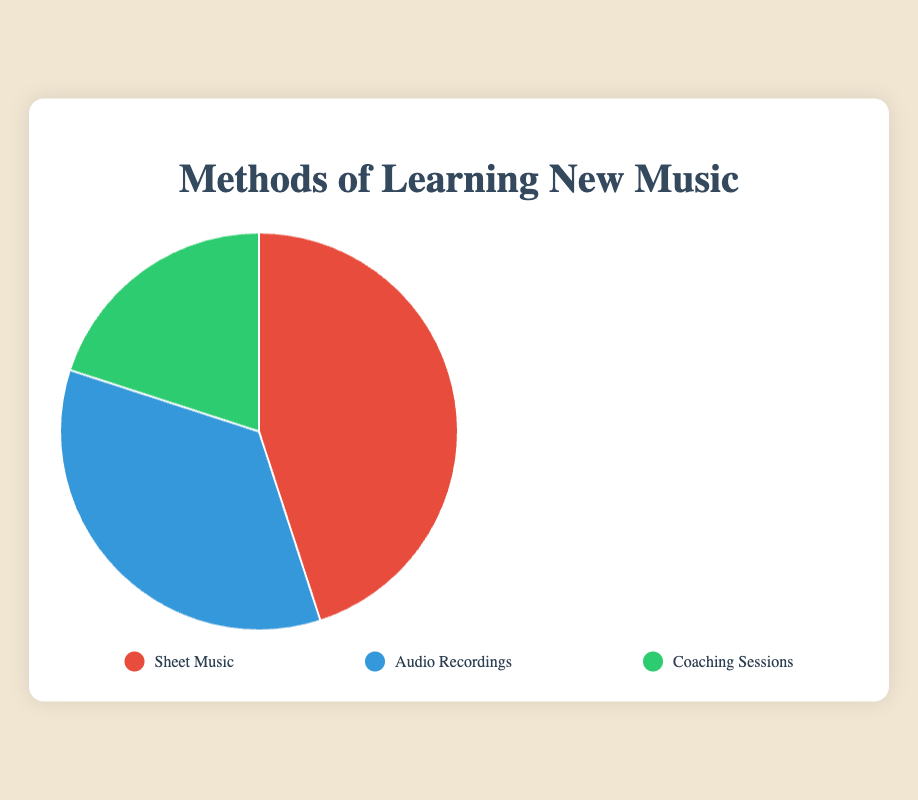What percentage of methods use Sheet Music? According to the pie chart, the percentage for Sheet Music is clearly indicated.
Answer: 45% What is the combined percentage of methods that use Audio Recordings and Coaching Sessions? The pie chart shows that Audio Recordings account for 35% and Coaching Sessions account for 20%. Summing these together, 35% + 20% gives the total percentage.
Answer: 55% Which method of learning new music is the most popular based on the chart? The largest segment in the pie chart corresponds to Sheet Music, with the highest percentage of 45%.
Answer: Sheet Music How many percentage points more does Sheet Music have compared to Coaching Sessions? Sheet Music has 45% and Coaching Sessions have 20%. The difference is calculated as 45% - 20%.
Answer: 25 What is the average percentage of all three methods combined? To find the average, we sum the percentages of all three methods: 45% + 35% + 20% = 100%. Then, we divide by the number of methods, which is 3. Thus, the average is 100% / 3.
Answer: 33.3% Which method has the smallest percentage, and what is it? The pie chart shows the smallest segment corresponds to Coaching Sessions, with a percentage of 20%.
Answer: Coaching Sessions, 20% Is the percentage of Audio Recordings greater than the percentage of Coaching Sessions? Yes, the percentage for Audio Recordings is 35%, while Coaching Sessions have 20%. Thus, 35% is greater than 20%.
Answer: Yes By how many more percentage points does Sheet Music surpass Audio Recordings? Sheet Music has 45% and Audio Recordings have 35%. The difference is calculated by subtracting 35% from 45%.
Answer: 10 How do the percentages of Audio Recordings and Coaching Sessions combined compare to Sheet Music? The combined percentage of Audio Recordings (35%) and Coaching Sessions (20%) is 55%. This is 10 percentage points more than Sheet Music, which is 45%.
Answer: Combined percentage is 10 points more What does the red color segment in the pie chart represent? The legend indicates that the red color represents Sheet Music.
Answer: Sheet Music 